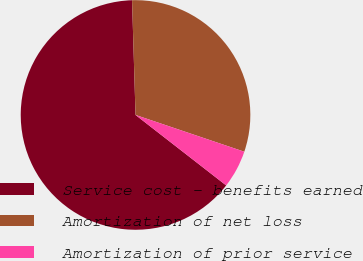<chart> <loc_0><loc_0><loc_500><loc_500><pie_chart><fcel>Service cost - benefits earned<fcel>Amortization of net loss<fcel>Amortization of prior service<nl><fcel>64.0%<fcel>30.67%<fcel>5.33%<nl></chart> 